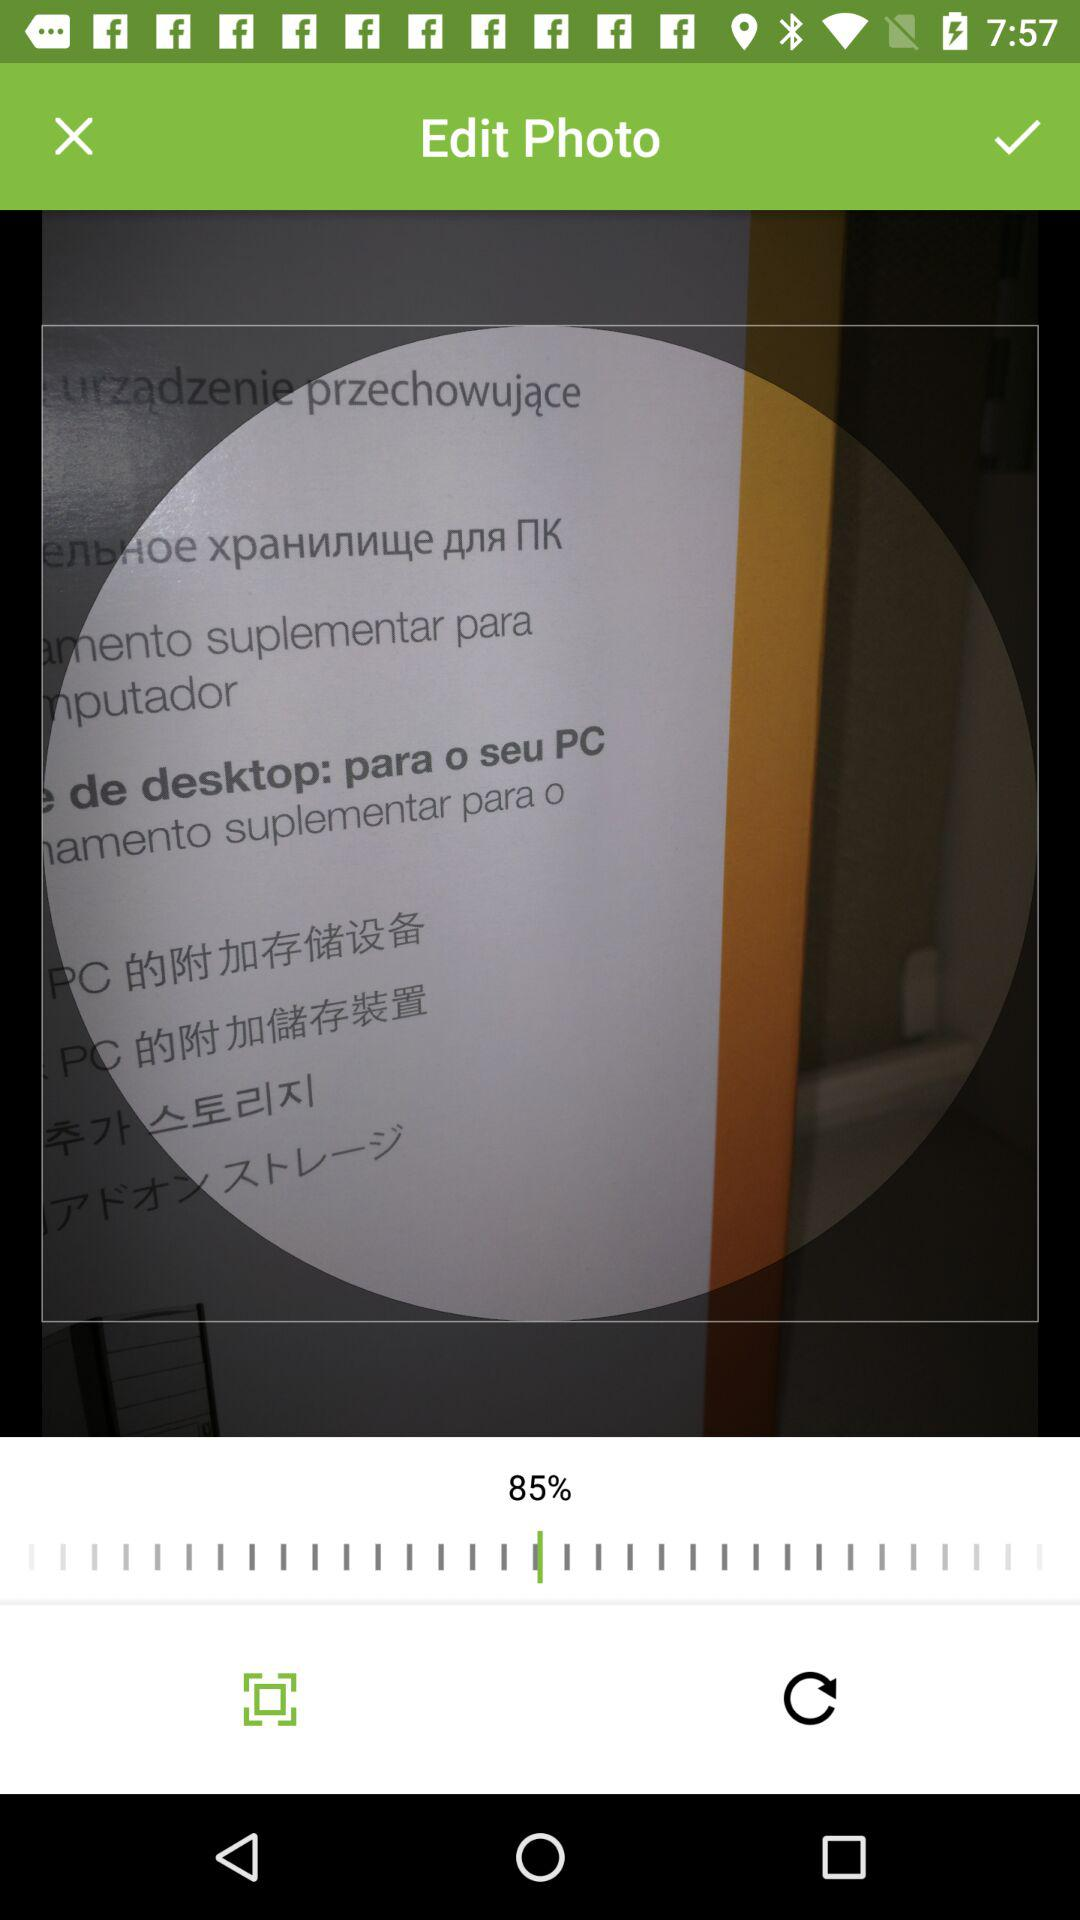What is the percentage of the circle that is filled in?
Answer the question using a single word or phrase. 85% 